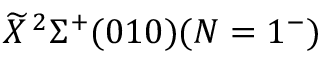Convert formula to latex. <formula><loc_0><loc_0><loc_500><loc_500>\widetilde { X } \, ^ { 2 } \Sigma ^ { + } ( 0 1 0 ) ( N = 1 ^ { - } )</formula> 